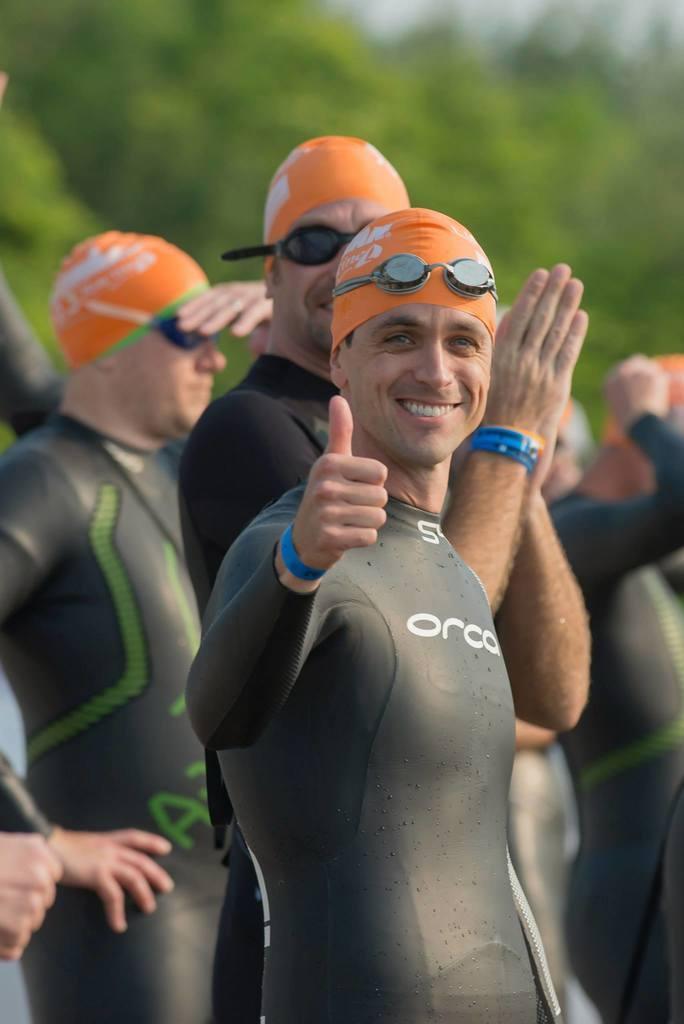How would you summarize this image in a sentence or two? In the image there are a group of men wearing swimming costumes and the first person is showing thumbs up with his hand and also smiling, the background of the man is blur. 